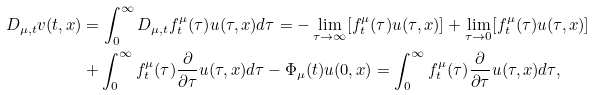<formula> <loc_0><loc_0><loc_500><loc_500>D _ { \mu , t } v ( t , x ) & = \int _ { 0 } ^ { \infty } D _ { \mu , t } { f ^ { \mu } _ { t } } { ( \tau ) } u ( \tau , x ) d \tau = - \lim _ { \tau \to \infty } [ f ^ { \mu } _ { t } ( \tau ) u ( \tau , x ) ] + \lim _ { \tau \to 0 } [ f ^ { \mu } _ { t } ( \tau ) u ( \tau , x ) ] \\ & + \int _ { 0 } ^ { \infty } f ^ { \mu } _ { t } ( \tau ) \frac { \partial } { \partial \tau } u ( \tau , x ) d \tau - \Phi _ { \mu } ( t ) u ( 0 , x ) = \int _ { 0 } ^ { \infty } f ^ { \mu } _ { t } ( \tau ) \frac { \partial } { \partial \tau } u ( \tau , x ) d \tau ,</formula> 